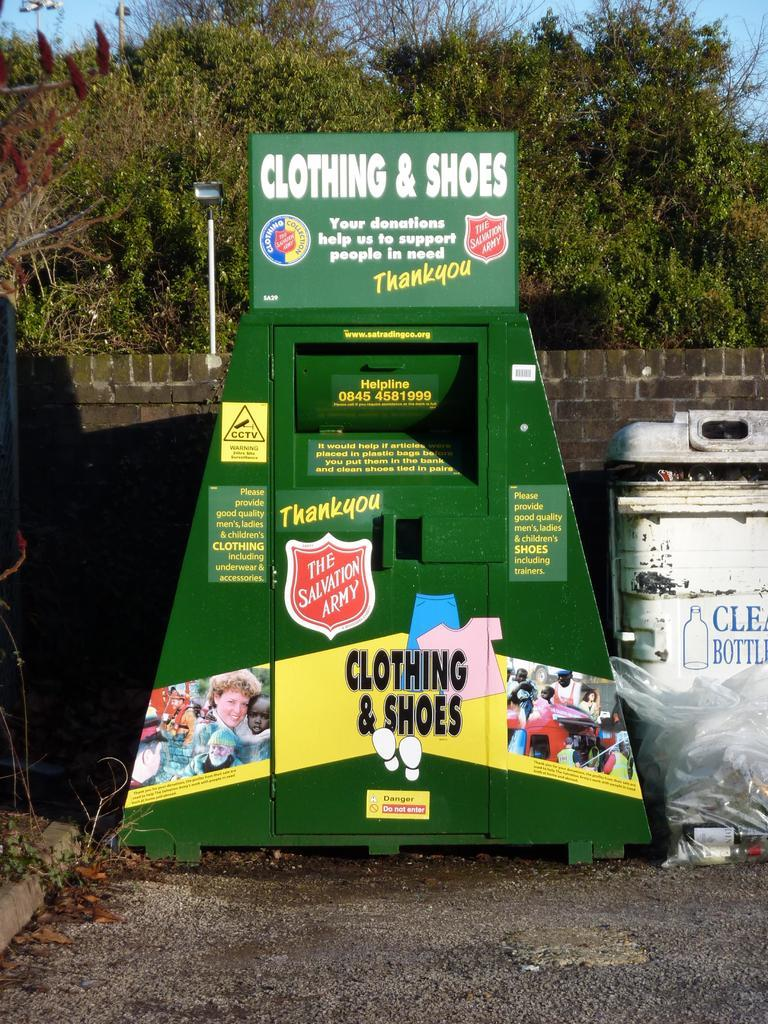<image>
Create a compact narrative representing the image presented. Clothing and shoes donation box from the salvation army 